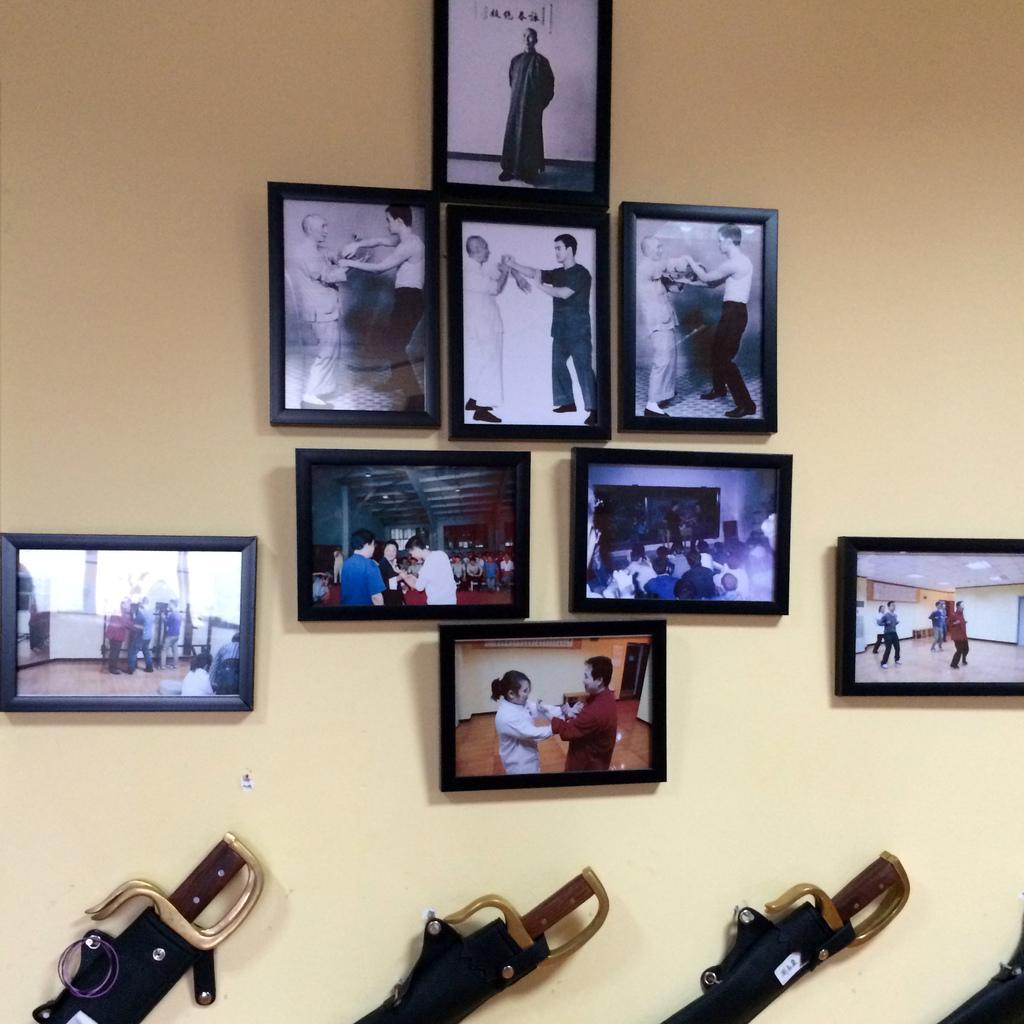How would you summarize this image in a sentence or two? In this picture we can see frames and swords on the wall. 